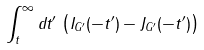<formula> <loc_0><loc_0><loc_500><loc_500>\int _ { t } ^ { \infty } d t ^ { \prime } \, \left ( I _ { G ^ { \prime } } ( - t ^ { \prime } ) - J _ { G ^ { \prime } } ( - t ^ { \prime } ) \right )</formula> 